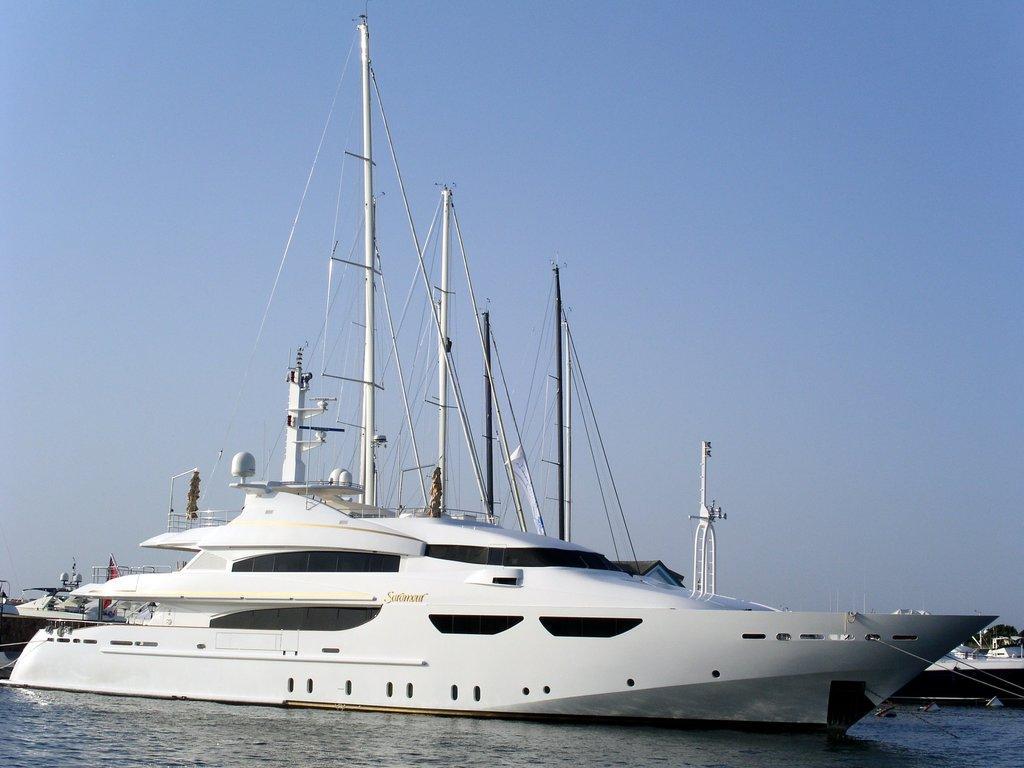Could you give a brief overview of what you see in this image? In this picture we can see water at the bottom, there is a ship in the middle, in the background we can see a tree, there is the sky at the top of the picture. 